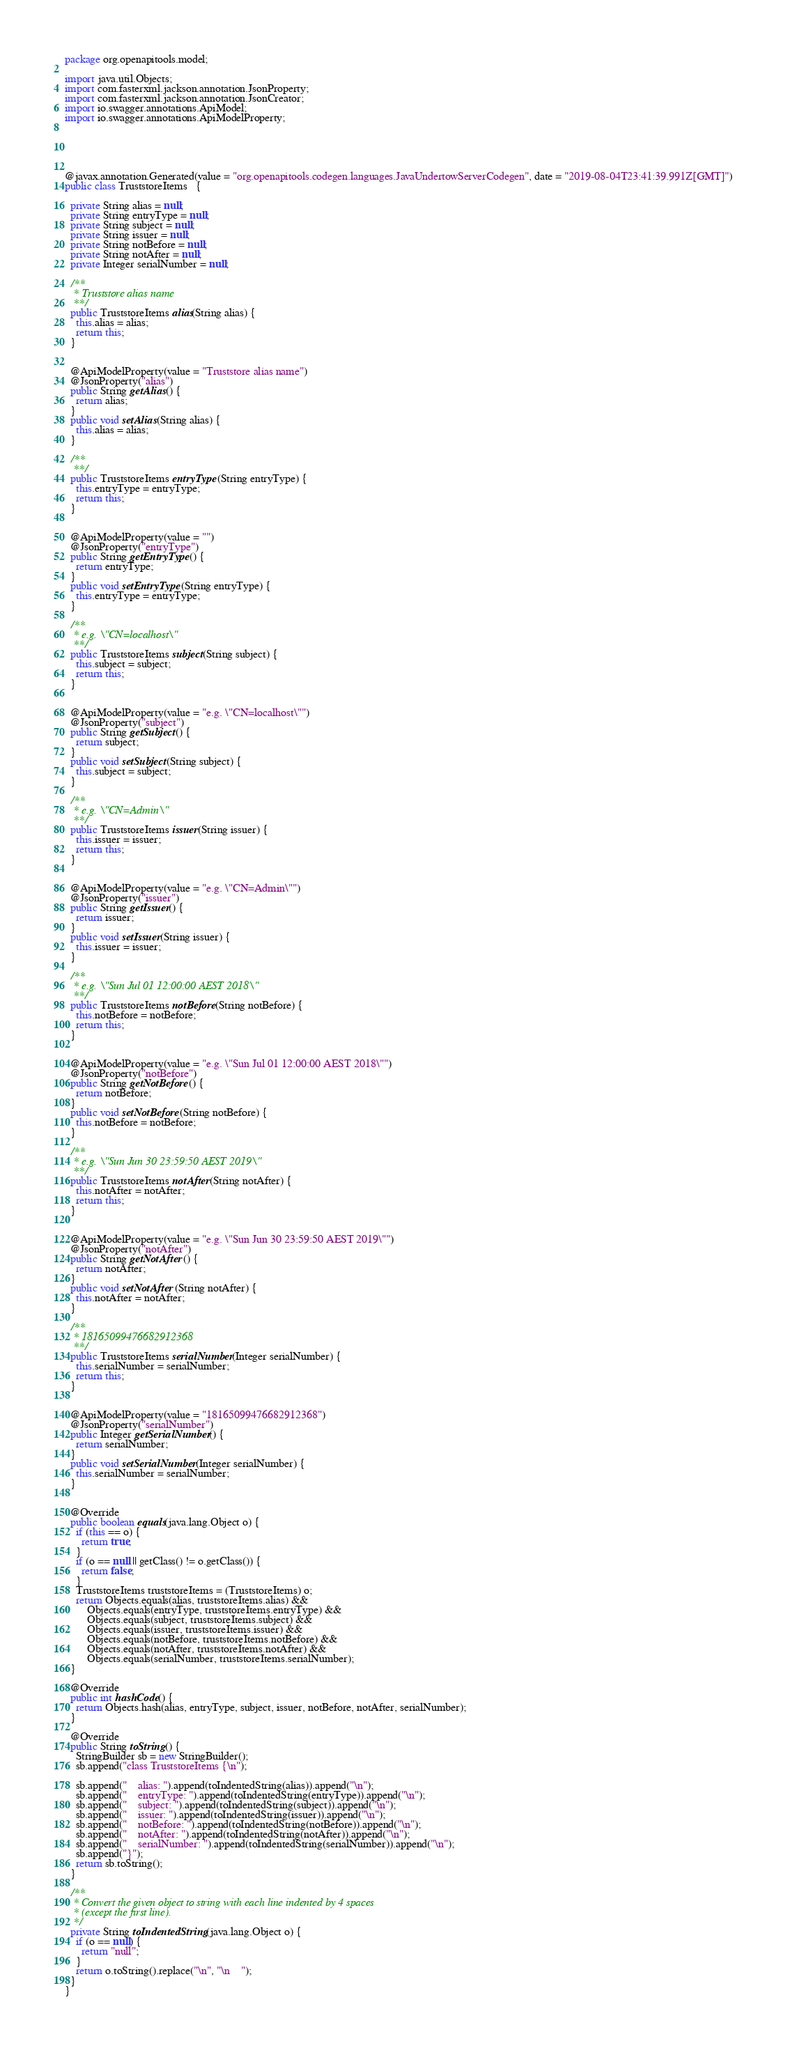Convert code to text. <code><loc_0><loc_0><loc_500><loc_500><_Java_>package org.openapitools.model;

import java.util.Objects;
import com.fasterxml.jackson.annotation.JsonProperty;
import com.fasterxml.jackson.annotation.JsonCreator;
import io.swagger.annotations.ApiModel;
import io.swagger.annotations.ApiModelProperty;





@javax.annotation.Generated(value = "org.openapitools.codegen.languages.JavaUndertowServerCodegen", date = "2019-08-04T23:41:39.991Z[GMT]")
public class TruststoreItems   {
  
  private String alias = null;
  private String entryType = null;
  private String subject = null;
  private String issuer = null;
  private String notBefore = null;
  private String notAfter = null;
  private Integer serialNumber = null;

  /**
   * Truststore alias name
   **/
  public TruststoreItems alias(String alias) {
    this.alias = alias;
    return this;
  }

  
  @ApiModelProperty(value = "Truststore alias name")
  @JsonProperty("alias")
  public String getAlias() {
    return alias;
  }
  public void setAlias(String alias) {
    this.alias = alias;
  }

  /**
   **/
  public TruststoreItems entryType(String entryType) {
    this.entryType = entryType;
    return this;
  }

  
  @ApiModelProperty(value = "")
  @JsonProperty("entryType")
  public String getEntryType() {
    return entryType;
  }
  public void setEntryType(String entryType) {
    this.entryType = entryType;
  }

  /**
   * e.g. \"CN=localhost\"
   **/
  public TruststoreItems subject(String subject) {
    this.subject = subject;
    return this;
  }

  
  @ApiModelProperty(value = "e.g. \"CN=localhost\"")
  @JsonProperty("subject")
  public String getSubject() {
    return subject;
  }
  public void setSubject(String subject) {
    this.subject = subject;
  }

  /**
   * e.g. \"CN=Admin\"
   **/
  public TruststoreItems issuer(String issuer) {
    this.issuer = issuer;
    return this;
  }

  
  @ApiModelProperty(value = "e.g. \"CN=Admin\"")
  @JsonProperty("issuer")
  public String getIssuer() {
    return issuer;
  }
  public void setIssuer(String issuer) {
    this.issuer = issuer;
  }

  /**
   * e.g. \"Sun Jul 01 12:00:00 AEST 2018\"
   **/
  public TruststoreItems notBefore(String notBefore) {
    this.notBefore = notBefore;
    return this;
  }

  
  @ApiModelProperty(value = "e.g. \"Sun Jul 01 12:00:00 AEST 2018\"")
  @JsonProperty("notBefore")
  public String getNotBefore() {
    return notBefore;
  }
  public void setNotBefore(String notBefore) {
    this.notBefore = notBefore;
  }

  /**
   * e.g. \"Sun Jun 30 23:59:50 AEST 2019\"
   **/
  public TruststoreItems notAfter(String notAfter) {
    this.notAfter = notAfter;
    return this;
  }

  
  @ApiModelProperty(value = "e.g. \"Sun Jun 30 23:59:50 AEST 2019\"")
  @JsonProperty("notAfter")
  public String getNotAfter() {
    return notAfter;
  }
  public void setNotAfter(String notAfter) {
    this.notAfter = notAfter;
  }

  /**
   * 18165099476682912368
   **/
  public TruststoreItems serialNumber(Integer serialNumber) {
    this.serialNumber = serialNumber;
    return this;
  }

  
  @ApiModelProperty(value = "18165099476682912368")
  @JsonProperty("serialNumber")
  public Integer getSerialNumber() {
    return serialNumber;
  }
  public void setSerialNumber(Integer serialNumber) {
    this.serialNumber = serialNumber;
  }


  @Override
  public boolean equals(java.lang.Object o) {
    if (this == o) {
      return true;
    }
    if (o == null || getClass() != o.getClass()) {
      return false;
    }
    TruststoreItems truststoreItems = (TruststoreItems) o;
    return Objects.equals(alias, truststoreItems.alias) &&
        Objects.equals(entryType, truststoreItems.entryType) &&
        Objects.equals(subject, truststoreItems.subject) &&
        Objects.equals(issuer, truststoreItems.issuer) &&
        Objects.equals(notBefore, truststoreItems.notBefore) &&
        Objects.equals(notAfter, truststoreItems.notAfter) &&
        Objects.equals(serialNumber, truststoreItems.serialNumber);
  }

  @Override
  public int hashCode() {
    return Objects.hash(alias, entryType, subject, issuer, notBefore, notAfter, serialNumber);
  }

  @Override
  public String toString() {
    StringBuilder sb = new StringBuilder();
    sb.append("class TruststoreItems {\n");
    
    sb.append("    alias: ").append(toIndentedString(alias)).append("\n");
    sb.append("    entryType: ").append(toIndentedString(entryType)).append("\n");
    sb.append("    subject: ").append(toIndentedString(subject)).append("\n");
    sb.append("    issuer: ").append(toIndentedString(issuer)).append("\n");
    sb.append("    notBefore: ").append(toIndentedString(notBefore)).append("\n");
    sb.append("    notAfter: ").append(toIndentedString(notAfter)).append("\n");
    sb.append("    serialNumber: ").append(toIndentedString(serialNumber)).append("\n");
    sb.append("}");
    return sb.toString();
  }

  /**
   * Convert the given object to string with each line indented by 4 spaces
   * (except the first line).
   */
  private String toIndentedString(java.lang.Object o) {
    if (o == null) {
      return "null";
    }
    return o.toString().replace("\n", "\n    ");
  }
}

</code> 